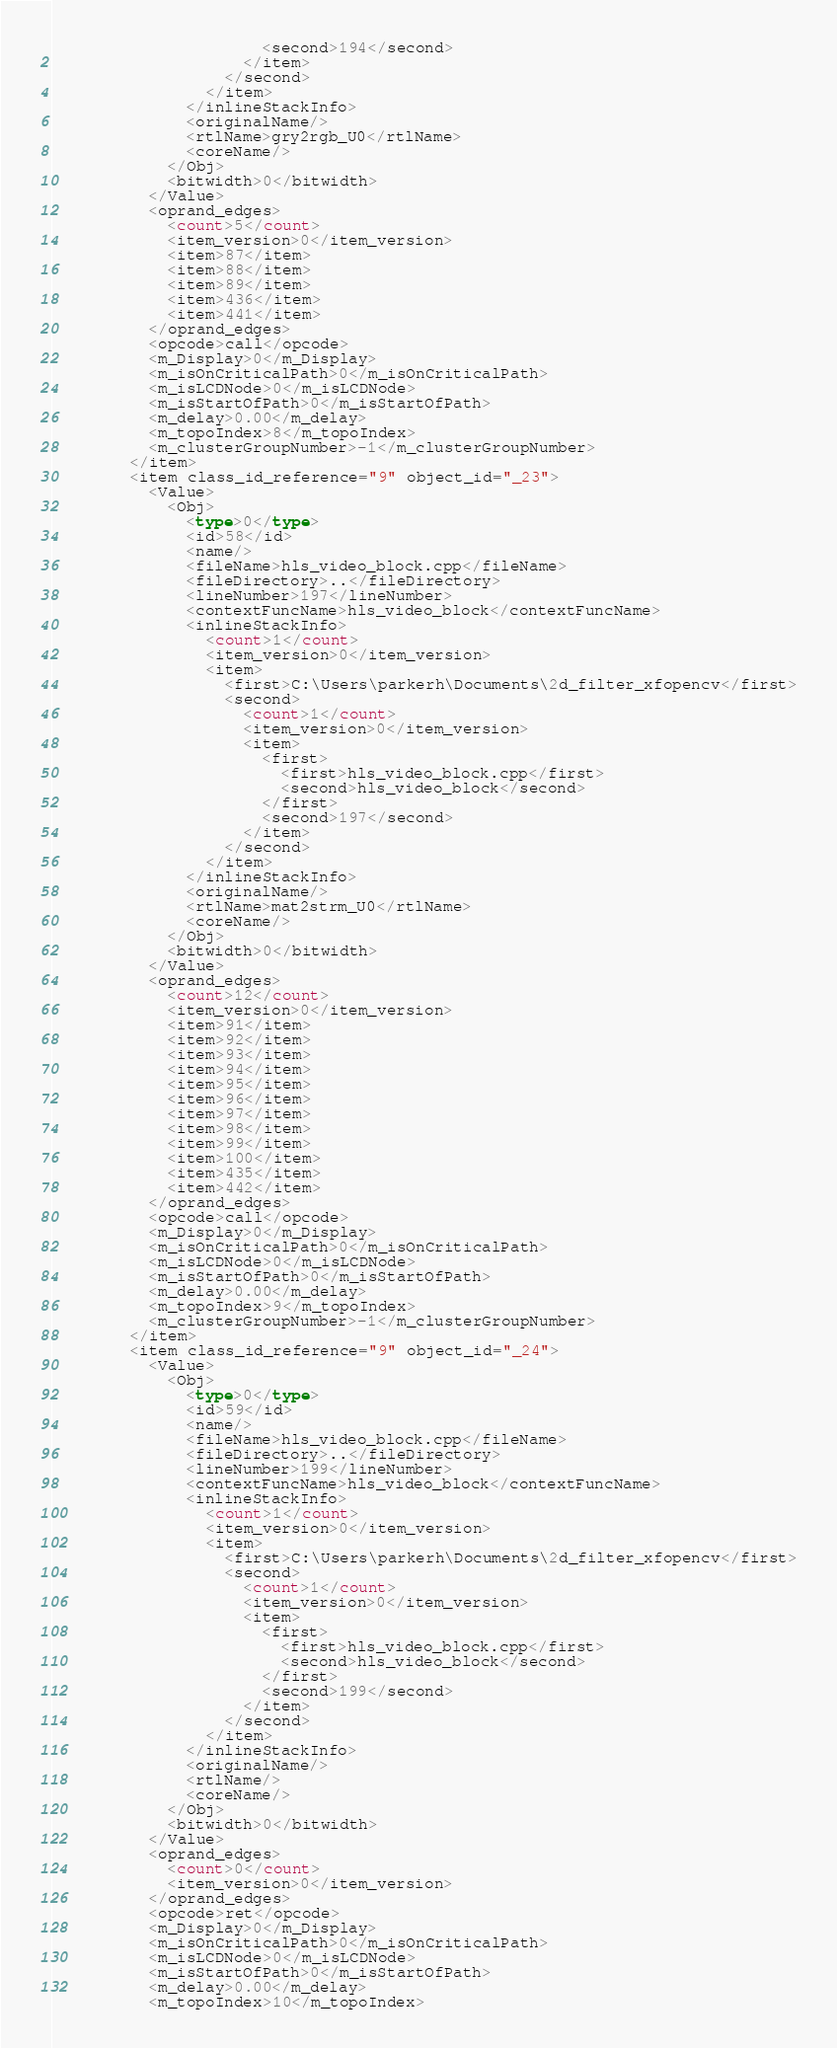Convert code to text. <code><loc_0><loc_0><loc_500><loc_500><_Ada_>                      <second>194</second>
                    </item>
                  </second>
                </item>
              </inlineStackInfo>
              <originalName/>
              <rtlName>gry2rgb_U0</rtlName>
              <coreName/>
            </Obj>
            <bitwidth>0</bitwidth>
          </Value>
          <oprand_edges>
            <count>5</count>
            <item_version>0</item_version>
            <item>87</item>
            <item>88</item>
            <item>89</item>
            <item>436</item>
            <item>441</item>
          </oprand_edges>
          <opcode>call</opcode>
          <m_Display>0</m_Display>
          <m_isOnCriticalPath>0</m_isOnCriticalPath>
          <m_isLCDNode>0</m_isLCDNode>
          <m_isStartOfPath>0</m_isStartOfPath>
          <m_delay>0.00</m_delay>
          <m_topoIndex>8</m_topoIndex>
          <m_clusterGroupNumber>-1</m_clusterGroupNumber>
        </item>
        <item class_id_reference="9" object_id="_23">
          <Value>
            <Obj>
              <type>0</type>
              <id>58</id>
              <name/>
              <fileName>hls_video_block.cpp</fileName>
              <fileDirectory>..</fileDirectory>
              <lineNumber>197</lineNumber>
              <contextFuncName>hls_video_block</contextFuncName>
              <inlineStackInfo>
                <count>1</count>
                <item_version>0</item_version>
                <item>
                  <first>C:\Users\parkerh\Documents\2d_filter_xfopencv</first>
                  <second>
                    <count>1</count>
                    <item_version>0</item_version>
                    <item>
                      <first>
                        <first>hls_video_block.cpp</first>
                        <second>hls_video_block</second>
                      </first>
                      <second>197</second>
                    </item>
                  </second>
                </item>
              </inlineStackInfo>
              <originalName/>
              <rtlName>mat2strm_U0</rtlName>
              <coreName/>
            </Obj>
            <bitwidth>0</bitwidth>
          </Value>
          <oprand_edges>
            <count>12</count>
            <item_version>0</item_version>
            <item>91</item>
            <item>92</item>
            <item>93</item>
            <item>94</item>
            <item>95</item>
            <item>96</item>
            <item>97</item>
            <item>98</item>
            <item>99</item>
            <item>100</item>
            <item>435</item>
            <item>442</item>
          </oprand_edges>
          <opcode>call</opcode>
          <m_Display>0</m_Display>
          <m_isOnCriticalPath>0</m_isOnCriticalPath>
          <m_isLCDNode>0</m_isLCDNode>
          <m_isStartOfPath>0</m_isStartOfPath>
          <m_delay>0.00</m_delay>
          <m_topoIndex>9</m_topoIndex>
          <m_clusterGroupNumber>-1</m_clusterGroupNumber>
        </item>
        <item class_id_reference="9" object_id="_24">
          <Value>
            <Obj>
              <type>0</type>
              <id>59</id>
              <name/>
              <fileName>hls_video_block.cpp</fileName>
              <fileDirectory>..</fileDirectory>
              <lineNumber>199</lineNumber>
              <contextFuncName>hls_video_block</contextFuncName>
              <inlineStackInfo>
                <count>1</count>
                <item_version>0</item_version>
                <item>
                  <first>C:\Users\parkerh\Documents\2d_filter_xfopencv</first>
                  <second>
                    <count>1</count>
                    <item_version>0</item_version>
                    <item>
                      <first>
                        <first>hls_video_block.cpp</first>
                        <second>hls_video_block</second>
                      </first>
                      <second>199</second>
                    </item>
                  </second>
                </item>
              </inlineStackInfo>
              <originalName/>
              <rtlName/>
              <coreName/>
            </Obj>
            <bitwidth>0</bitwidth>
          </Value>
          <oprand_edges>
            <count>0</count>
            <item_version>0</item_version>
          </oprand_edges>
          <opcode>ret</opcode>
          <m_Display>0</m_Display>
          <m_isOnCriticalPath>0</m_isOnCriticalPath>
          <m_isLCDNode>0</m_isLCDNode>
          <m_isStartOfPath>0</m_isStartOfPath>
          <m_delay>0.00</m_delay>
          <m_topoIndex>10</m_topoIndex></code> 